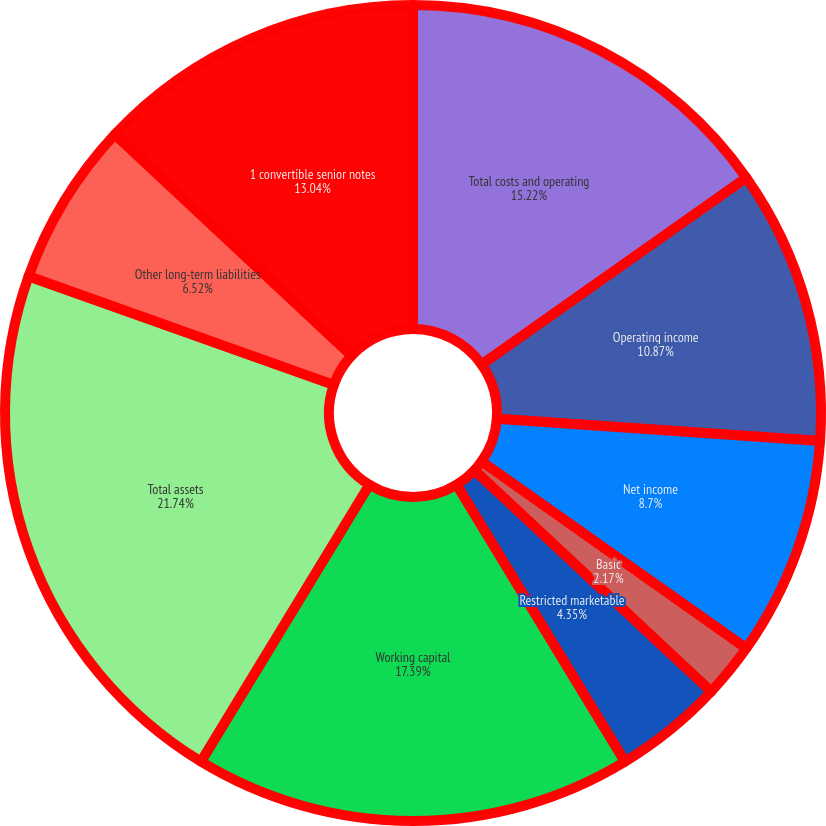Convert chart to OTSL. <chart><loc_0><loc_0><loc_500><loc_500><pie_chart><fcel>Total costs and operating<fcel>Operating income<fcel>Net income<fcel>Basic<fcel>Diluted<fcel>Restricted marketable<fcel>Working capital<fcel>Total assets<fcel>Other long-term liabilities<fcel>1 convertible senior notes<nl><fcel>15.22%<fcel>10.87%<fcel>8.7%<fcel>2.17%<fcel>0.0%<fcel>4.35%<fcel>17.39%<fcel>21.74%<fcel>6.52%<fcel>13.04%<nl></chart> 